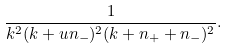<formula> <loc_0><loc_0><loc_500><loc_500>\frac { 1 } { k ^ { 2 } ( k + u n _ { - } ) ^ { 2 } ( k + n _ { + } + n _ { - } ) ^ { 2 } } .</formula> 